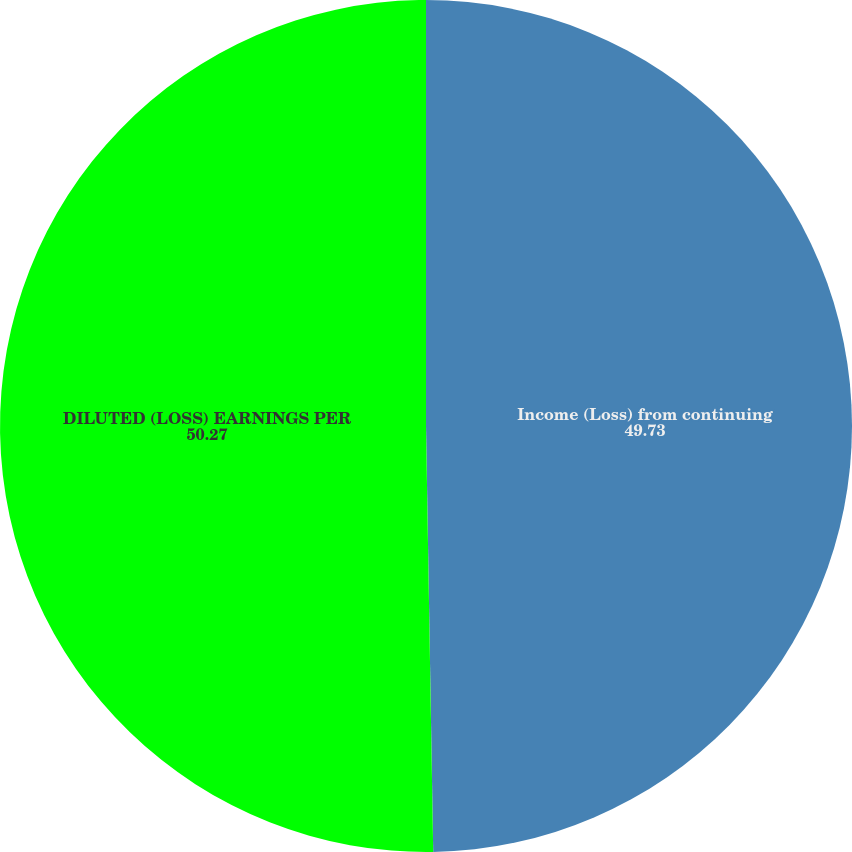Convert chart to OTSL. <chart><loc_0><loc_0><loc_500><loc_500><pie_chart><fcel>Income (Loss) from continuing<fcel>DILUTED (LOSS) EARNINGS PER<nl><fcel>49.73%<fcel>50.27%<nl></chart> 